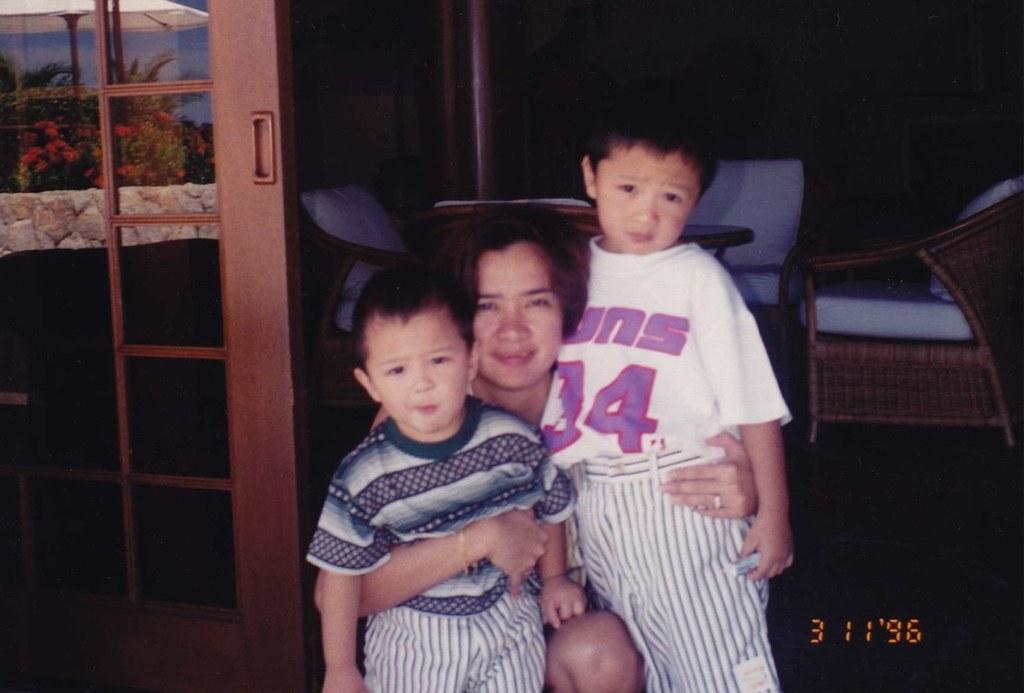Can you describe this image briefly? In this picture we can see a woman with two children. These are the chairs. And there is a door. Here we can see some trees and these are the red color flowers. 